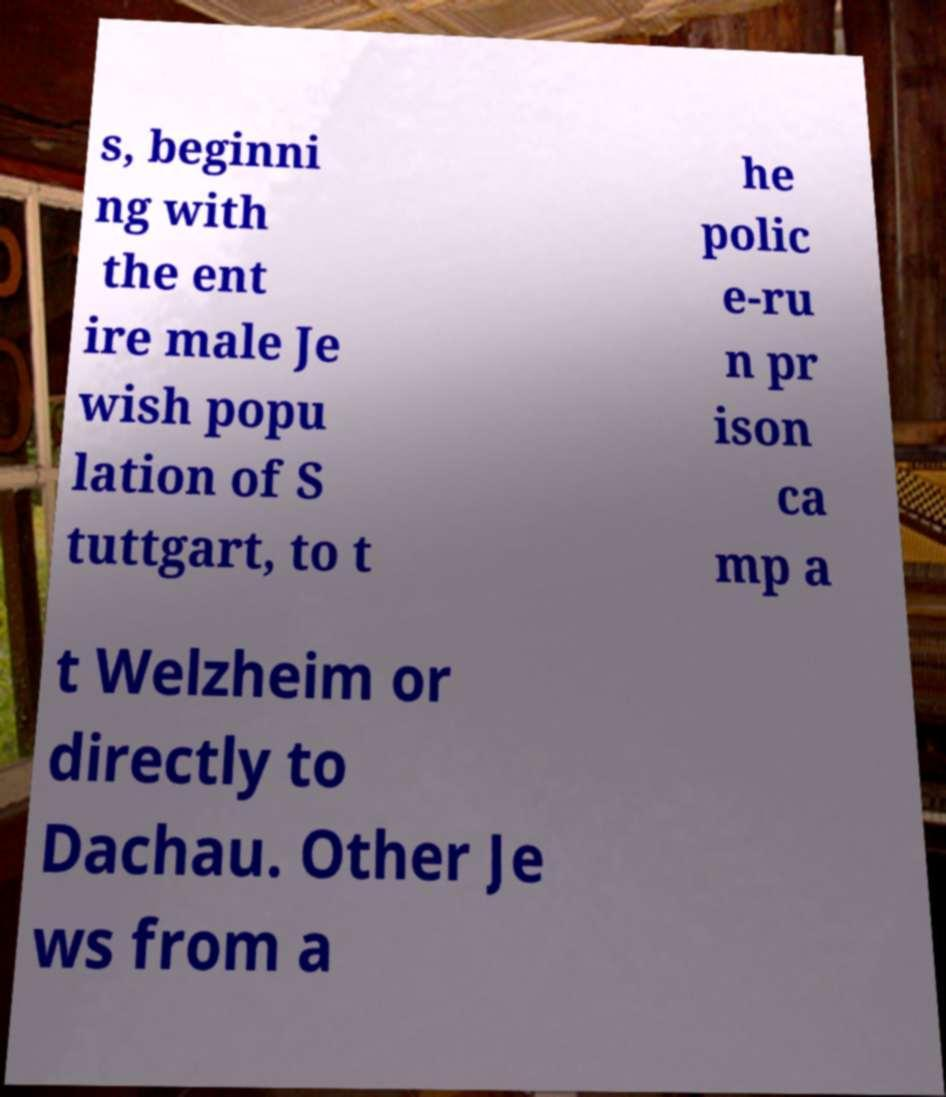Can you read and provide the text displayed in the image?This photo seems to have some interesting text. Can you extract and type it out for me? s, beginni ng with the ent ire male Je wish popu lation of S tuttgart, to t he polic e-ru n pr ison ca mp a t Welzheim or directly to Dachau. Other Je ws from a 